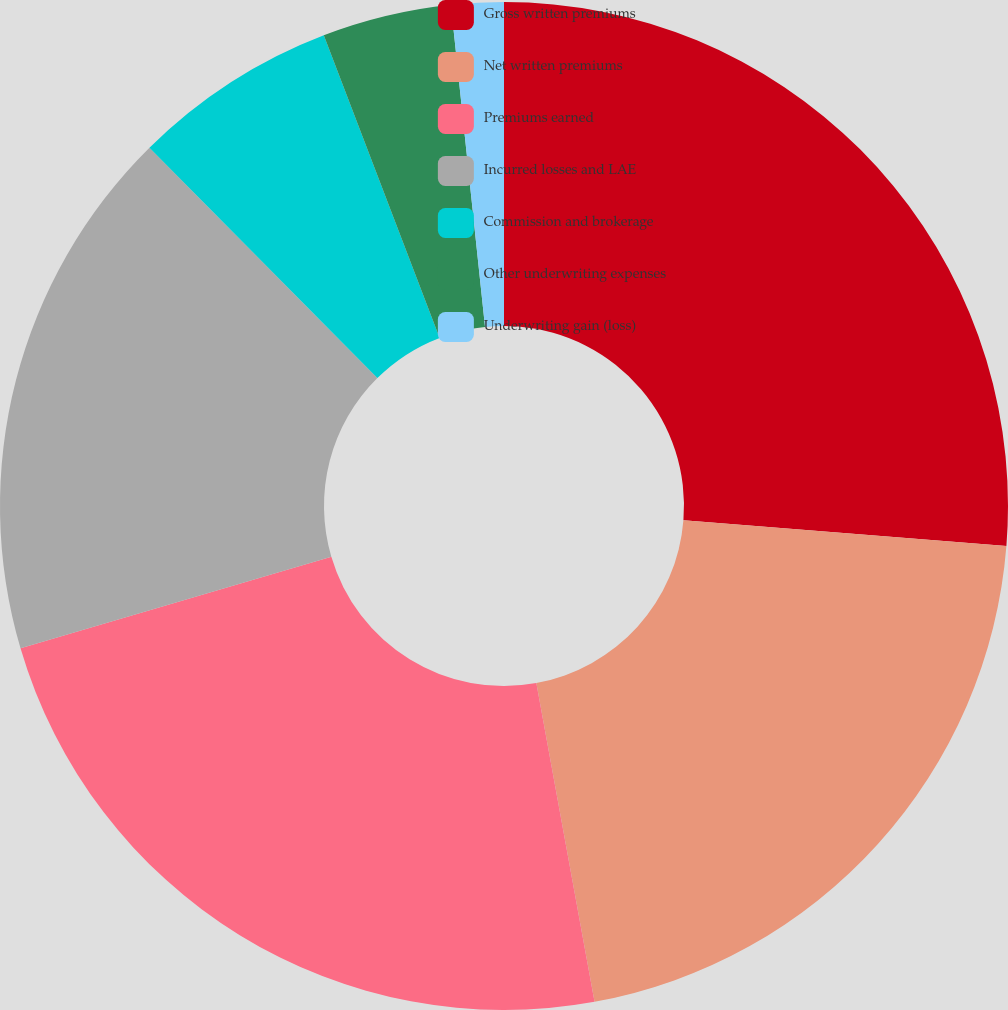<chart> <loc_0><loc_0><loc_500><loc_500><pie_chart><fcel>Gross written premiums<fcel>Net written premiums<fcel>Premiums earned<fcel>Incurred losses and LAE<fcel>Commission and brokerage<fcel>Other underwriting expenses<fcel>Underwriting gain (loss)<nl><fcel>26.27%<fcel>20.86%<fcel>23.32%<fcel>17.14%<fcel>6.6%<fcel>4.14%<fcel>1.68%<nl></chart> 